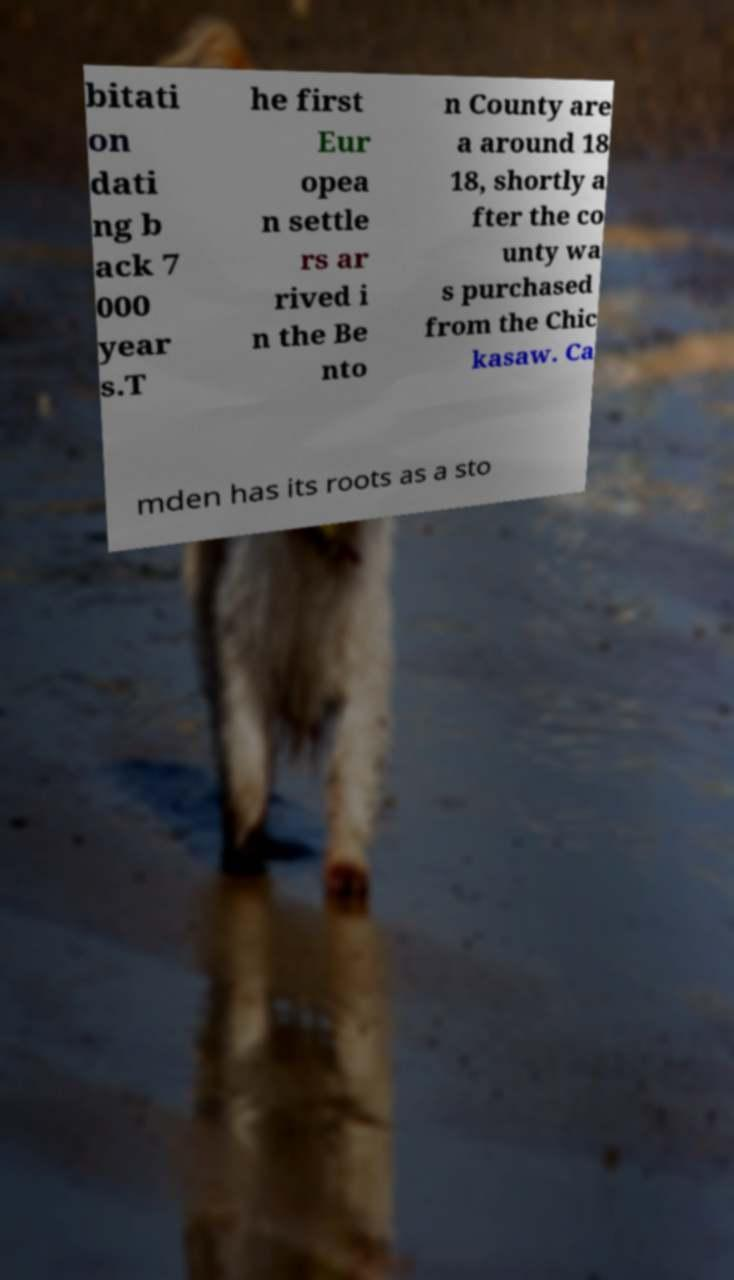There's text embedded in this image that I need extracted. Can you transcribe it verbatim? bitati on dati ng b ack 7 000 year s.T he first Eur opea n settle rs ar rived i n the Be nto n County are a around 18 18, shortly a fter the co unty wa s purchased from the Chic kasaw. Ca mden has its roots as a sto 